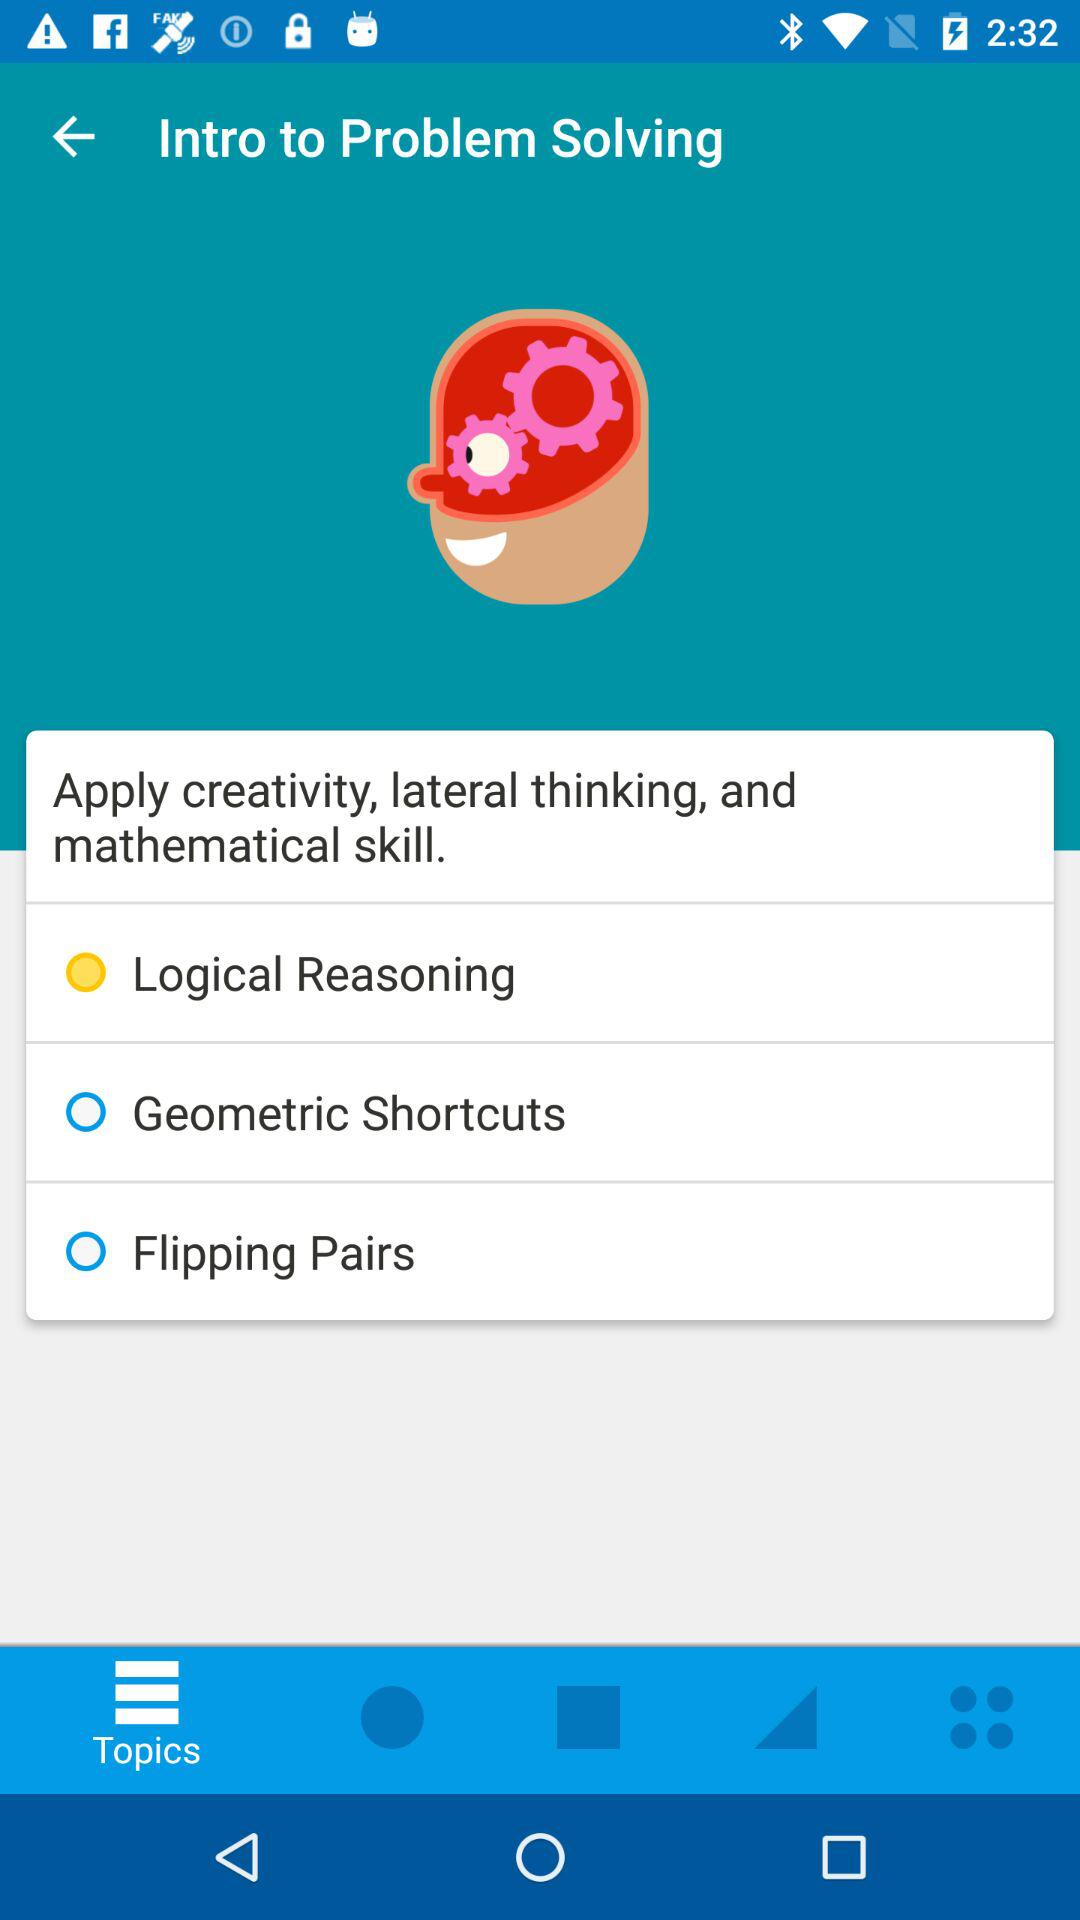Which is the selected option? The selected option is "Logical Reasoning". 